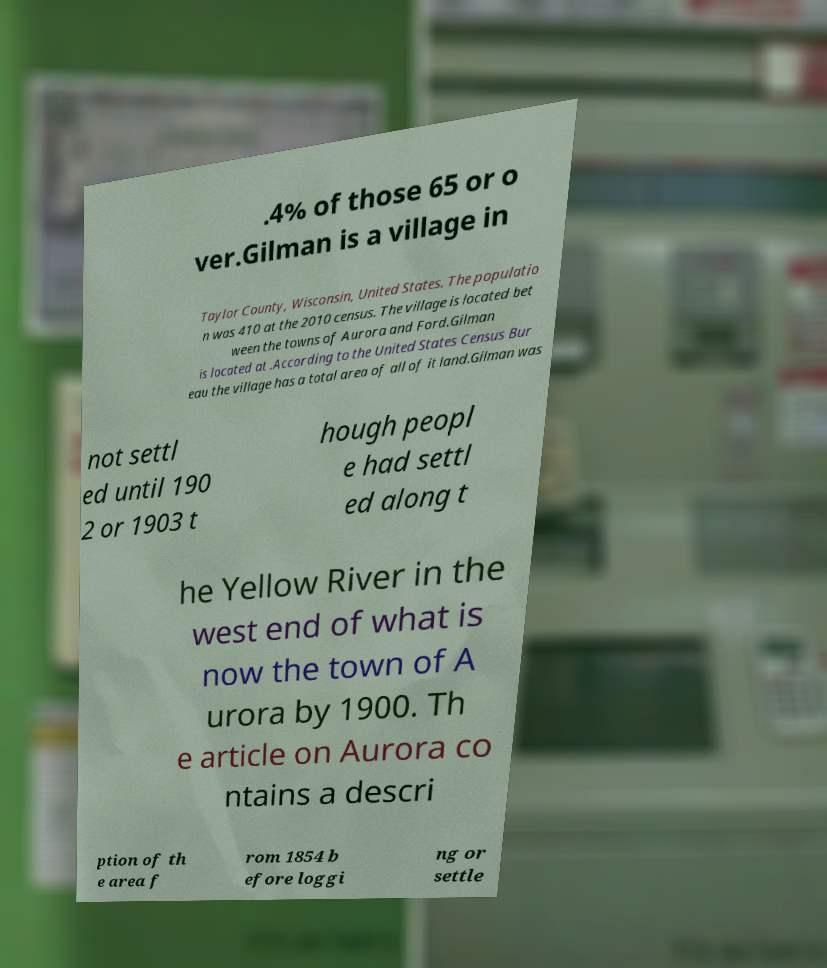I need the written content from this picture converted into text. Can you do that? .4% of those 65 or o ver.Gilman is a village in Taylor County, Wisconsin, United States. The populatio n was 410 at the 2010 census. The village is located bet ween the towns of Aurora and Ford.Gilman is located at .According to the United States Census Bur eau the village has a total area of all of it land.Gilman was not settl ed until 190 2 or 1903 t hough peopl e had settl ed along t he Yellow River in the west end of what is now the town of A urora by 1900. Th e article on Aurora co ntains a descri ption of th e area f rom 1854 b efore loggi ng or settle 